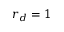<formula> <loc_0><loc_0><loc_500><loc_500>r _ { d } = 1</formula> 